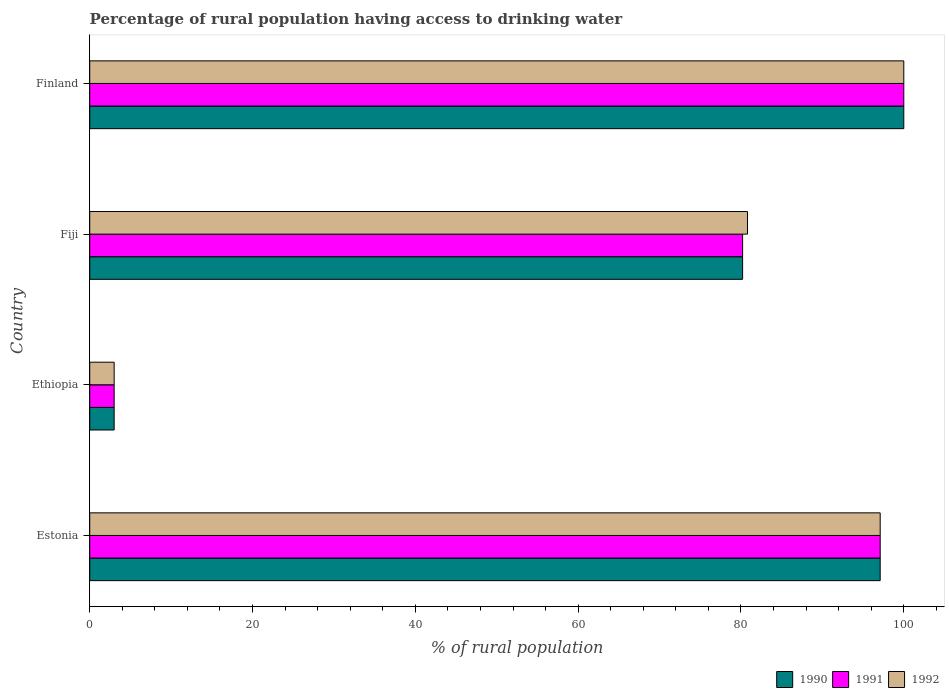Are the number of bars per tick equal to the number of legend labels?
Make the answer very short. Yes. Are the number of bars on each tick of the Y-axis equal?
Provide a short and direct response. Yes. How many bars are there on the 2nd tick from the top?
Ensure brevity in your answer.  3. How many bars are there on the 4th tick from the bottom?
Your answer should be very brief. 3. What is the label of the 2nd group of bars from the top?
Keep it short and to the point. Fiji. Across all countries, what is the maximum percentage of rural population having access to drinking water in 1991?
Your answer should be very brief. 100. Across all countries, what is the minimum percentage of rural population having access to drinking water in 1990?
Provide a short and direct response. 3. In which country was the percentage of rural population having access to drinking water in 1991 minimum?
Ensure brevity in your answer.  Ethiopia. What is the total percentage of rural population having access to drinking water in 1991 in the graph?
Make the answer very short. 280.3. What is the difference between the percentage of rural population having access to drinking water in 1992 in Estonia and that in Ethiopia?
Your answer should be compact. 94.1. What is the difference between the percentage of rural population having access to drinking water in 1990 in Estonia and the percentage of rural population having access to drinking water in 1991 in Ethiopia?
Give a very brief answer. 94.1. What is the average percentage of rural population having access to drinking water in 1991 per country?
Provide a succinct answer. 70.08. What is the difference between the percentage of rural population having access to drinking water in 1991 and percentage of rural population having access to drinking water in 1990 in Fiji?
Keep it short and to the point. 0. In how many countries, is the percentage of rural population having access to drinking water in 1990 greater than 76 %?
Offer a terse response. 3. What is the ratio of the percentage of rural population having access to drinking water in 1990 in Fiji to that in Finland?
Your answer should be compact. 0.8. Is the percentage of rural population having access to drinking water in 1990 in Estonia less than that in Ethiopia?
Your answer should be compact. No. Is the difference between the percentage of rural population having access to drinking water in 1991 in Ethiopia and Fiji greater than the difference between the percentage of rural population having access to drinking water in 1990 in Ethiopia and Fiji?
Your answer should be very brief. No. What is the difference between the highest and the second highest percentage of rural population having access to drinking water in 1990?
Keep it short and to the point. 2.9. What is the difference between the highest and the lowest percentage of rural population having access to drinking water in 1992?
Your answer should be very brief. 97. What does the 2nd bar from the bottom in Finland represents?
Give a very brief answer. 1991. Is it the case that in every country, the sum of the percentage of rural population having access to drinking water in 1991 and percentage of rural population having access to drinking water in 1990 is greater than the percentage of rural population having access to drinking water in 1992?
Give a very brief answer. Yes. How many bars are there?
Keep it short and to the point. 12. Are all the bars in the graph horizontal?
Your answer should be compact. Yes. Where does the legend appear in the graph?
Provide a short and direct response. Bottom right. How many legend labels are there?
Offer a very short reply. 3. How are the legend labels stacked?
Your response must be concise. Horizontal. What is the title of the graph?
Keep it short and to the point. Percentage of rural population having access to drinking water. Does "1973" appear as one of the legend labels in the graph?
Offer a very short reply. No. What is the label or title of the X-axis?
Keep it short and to the point. % of rural population. What is the % of rural population of 1990 in Estonia?
Keep it short and to the point. 97.1. What is the % of rural population of 1991 in Estonia?
Provide a short and direct response. 97.1. What is the % of rural population of 1992 in Estonia?
Provide a short and direct response. 97.1. What is the % of rural population of 1991 in Ethiopia?
Provide a succinct answer. 3. What is the % of rural population of 1992 in Ethiopia?
Offer a very short reply. 3. What is the % of rural population of 1990 in Fiji?
Your answer should be very brief. 80.2. What is the % of rural population in 1991 in Fiji?
Ensure brevity in your answer.  80.2. What is the % of rural population of 1992 in Fiji?
Your answer should be very brief. 80.8. What is the % of rural population of 1991 in Finland?
Your answer should be very brief. 100. What is the % of rural population of 1992 in Finland?
Ensure brevity in your answer.  100. Across all countries, what is the maximum % of rural population in 1991?
Your answer should be very brief. 100. Across all countries, what is the maximum % of rural population of 1992?
Offer a terse response. 100. Across all countries, what is the minimum % of rural population of 1990?
Your answer should be very brief. 3. Across all countries, what is the minimum % of rural population of 1992?
Your answer should be very brief. 3. What is the total % of rural population in 1990 in the graph?
Offer a terse response. 280.3. What is the total % of rural population of 1991 in the graph?
Provide a succinct answer. 280.3. What is the total % of rural population of 1992 in the graph?
Make the answer very short. 280.9. What is the difference between the % of rural population in 1990 in Estonia and that in Ethiopia?
Your answer should be compact. 94.1. What is the difference between the % of rural population of 1991 in Estonia and that in Ethiopia?
Ensure brevity in your answer.  94.1. What is the difference between the % of rural population in 1992 in Estonia and that in Ethiopia?
Offer a very short reply. 94.1. What is the difference between the % of rural population of 1990 in Estonia and that in Fiji?
Provide a succinct answer. 16.9. What is the difference between the % of rural population of 1992 in Estonia and that in Fiji?
Provide a succinct answer. 16.3. What is the difference between the % of rural population in 1991 in Estonia and that in Finland?
Offer a very short reply. -2.9. What is the difference between the % of rural population of 1990 in Ethiopia and that in Fiji?
Provide a short and direct response. -77.2. What is the difference between the % of rural population of 1991 in Ethiopia and that in Fiji?
Make the answer very short. -77.2. What is the difference between the % of rural population of 1992 in Ethiopia and that in Fiji?
Provide a short and direct response. -77.8. What is the difference between the % of rural population in 1990 in Ethiopia and that in Finland?
Make the answer very short. -97. What is the difference between the % of rural population in 1991 in Ethiopia and that in Finland?
Give a very brief answer. -97. What is the difference between the % of rural population in 1992 in Ethiopia and that in Finland?
Make the answer very short. -97. What is the difference between the % of rural population of 1990 in Fiji and that in Finland?
Keep it short and to the point. -19.8. What is the difference between the % of rural population of 1991 in Fiji and that in Finland?
Make the answer very short. -19.8. What is the difference between the % of rural population of 1992 in Fiji and that in Finland?
Offer a terse response. -19.2. What is the difference between the % of rural population of 1990 in Estonia and the % of rural population of 1991 in Ethiopia?
Give a very brief answer. 94.1. What is the difference between the % of rural population of 1990 in Estonia and the % of rural population of 1992 in Ethiopia?
Your response must be concise. 94.1. What is the difference between the % of rural population in 1991 in Estonia and the % of rural population in 1992 in Ethiopia?
Ensure brevity in your answer.  94.1. What is the difference between the % of rural population in 1990 in Estonia and the % of rural population in 1992 in Fiji?
Your answer should be very brief. 16.3. What is the difference between the % of rural population in 1991 in Estonia and the % of rural population in 1992 in Fiji?
Offer a terse response. 16.3. What is the difference between the % of rural population in 1990 in Estonia and the % of rural population in 1991 in Finland?
Make the answer very short. -2.9. What is the difference between the % of rural population of 1990 in Estonia and the % of rural population of 1992 in Finland?
Offer a very short reply. -2.9. What is the difference between the % of rural population of 1990 in Ethiopia and the % of rural population of 1991 in Fiji?
Your answer should be compact. -77.2. What is the difference between the % of rural population in 1990 in Ethiopia and the % of rural population in 1992 in Fiji?
Your answer should be very brief. -77.8. What is the difference between the % of rural population of 1991 in Ethiopia and the % of rural population of 1992 in Fiji?
Offer a very short reply. -77.8. What is the difference between the % of rural population in 1990 in Ethiopia and the % of rural population in 1991 in Finland?
Provide a short and direct response. -97. What is the difference between the % of rural population of 1990 in Ethiopia and the % of rural population of 1992 in Finland?
Keep it short and to the point. -97. What is the difference between the % of rural population of 1991 in Ethiopia and the % of rural population of 1992 in Finland?
Provide a succinct answer. -97. What is the difference between the % of rural population in 1990 in Fiji and the % of rural population in 1991 in Finland?
Keep it short and to the point. -19.8. What is the difference between the % of rural population of 1990 in Fiji and the % of rural population of 1992 in Finland?
Your answer should be compact. -19.8. What is the difference between the % of rural population in 1991 in Fiji and the % of rural population in 1992 in Finland?
Your response must be concise. -19.8. What is the average % of rural population in 1990 per country?
Make the answer very short. 70.08. What is the average % of rural population in 1991 per country?
Give a very brief answer. 70.08. What is the average % of rural population of 1992 per country?
Offer a terse response. 70.22. What is the difference between the % of rural population in 1990 and % of rural population in 1992 in Estonia?
Keep it short and to the point. 0. What is the difference between the % of rural population in 1991 and % of rural population in 1992 in Estonia?
Give a very brief answer. 0. What is the difference between the % of rural population in 1990 and % of rural population in 1991 in Ethiopia?
Offer a very short reply. 0. What is the difference between the % of rural population in 1990 and % of rural population in 1992 in Ethiopia?
Provide a short and direct response. 0. What is the difference between the % of rural population of 1991 and % of rural population of 1992 in Ethiopia?
Give a very brief answer. 0. What is the difference between the % of rural population in 1990 and % of rural population in 1992 in Fiji?
Provide a short and direct response. -0.6. What is the difference between the % of rural population in 1991 and % of rural population in 1992 in Fiji?
Provide a short and direct response. -0.6. What is the difference between the % of rural population of 1990 and % of rural population of 1991 in Finland?
Your answer should be very brief. 0. What is the ratio of the % of rural population in 1990 in Estonia to that in Ethiopia?
Give a very brief answer. 32.37. What is the ratio of the % of rural population in 1991 in Estonia to that in Ethiopia?
Keep it short and to the point. 32.37. What is the ratio of the % of rural population of 1992 in Estonia to that in Ethiopia?
Provide a succinct answer. 32.37. What is the ratio of the % of rural population of 1990 in Estonia to that in Fiji?
Your answer should be very brief. 1.21. What is the ratio of the % of rural population of 1991 in Estonia to that in Fiji?
Offer a very short reply. 1.21. What is the ratio of the % of rural population in 1992 in Estonia to that in Fiji?
Provide a short and direct response. 1.2. What is the ratio of the % of rural population in 1992 in Estonia to that in Finland?
Give a very brief answer. 0.97. What is the ratio of the % of rural population of 1990 in Ethiopia to that in Fiji?
Keep it short and to the point. 0.04. What is the ratio of the % of rural population in 1991 in Ethiopia to that in Fiji?
Provide a short and direct response. 0.04. What is the ratio of the % of rural population in 1992 in Ethiopia to that in Fiji?
Offer a very short reply. 0.04. What is the ratio of the % of rural population in 1992 in Ethiopia to that in Finland?
Give a very brief answer. 0.03. What is the ratio of the % of rural population in 1990 in Fiji to that in Finland?
Keep it short and to the point. 0.8. What is the ratio of the % of rural population of 1991 in Fiji to that in Finland?
Your answer should be very brief. 0.8. What is the ratio of the % of rural population of 1992 in Fiji to that in Finland?
Make the answer very short. 0.81. What is the difference between the highest and the second highest % of rural population of 1992?
Make the answer very short. 2.9. What is the difference between the highest and the lowest % of rural population in 1990?
Your answer should be very brief. 97. What is the difference between the highest and the lowest % of rural population of 1991?
Your answer should be very brief. 97. What is the difference between the highest and the lowest % of rural population of 1992?
Provide a succinct answer. 97. 